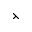Convert formula to latex. <formula><loc_0><loc_0><loc_500><loc_500>\left t h r e e t i m e s</formula> 